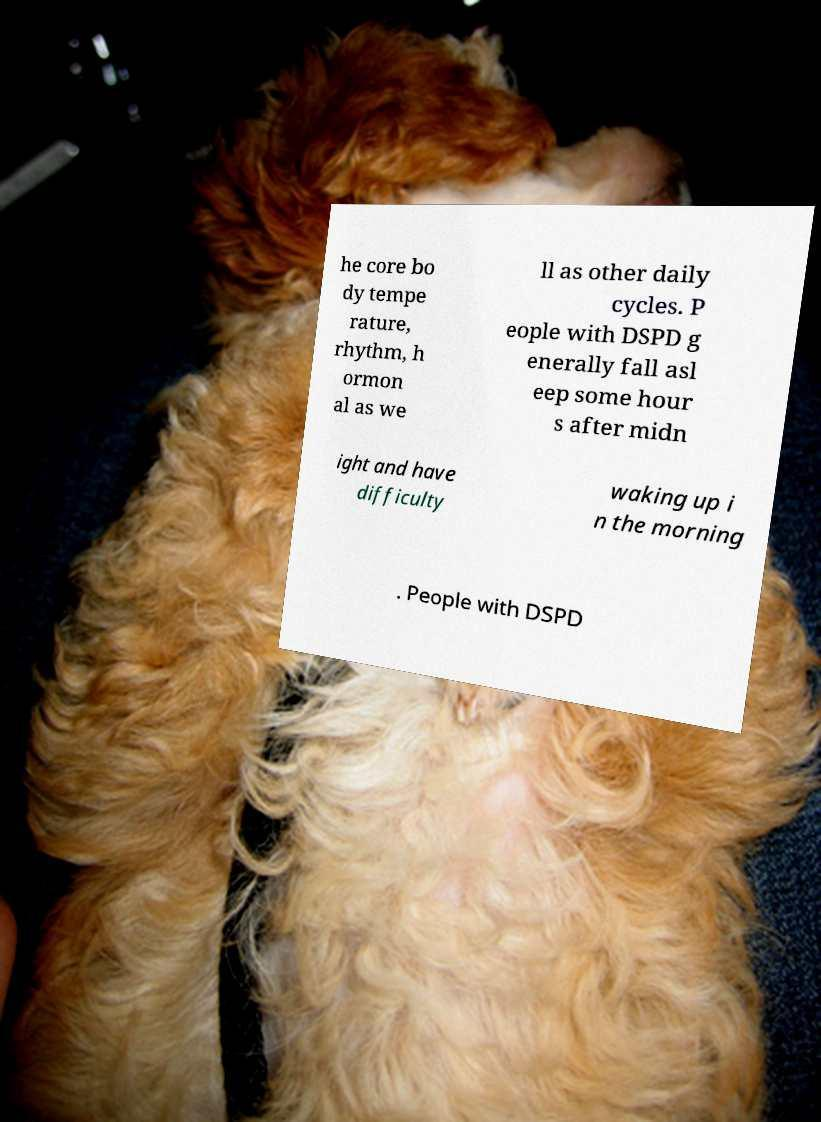Please identify and transcribe the text found in this image. he core bo dy tempe rature, rhythm, h ormon al as we ll as other daily cycles. P eople with DSPD g enerally fall asl eep some hour s after midn ight and have difficulty waking up i n the morning . People with DSPD 